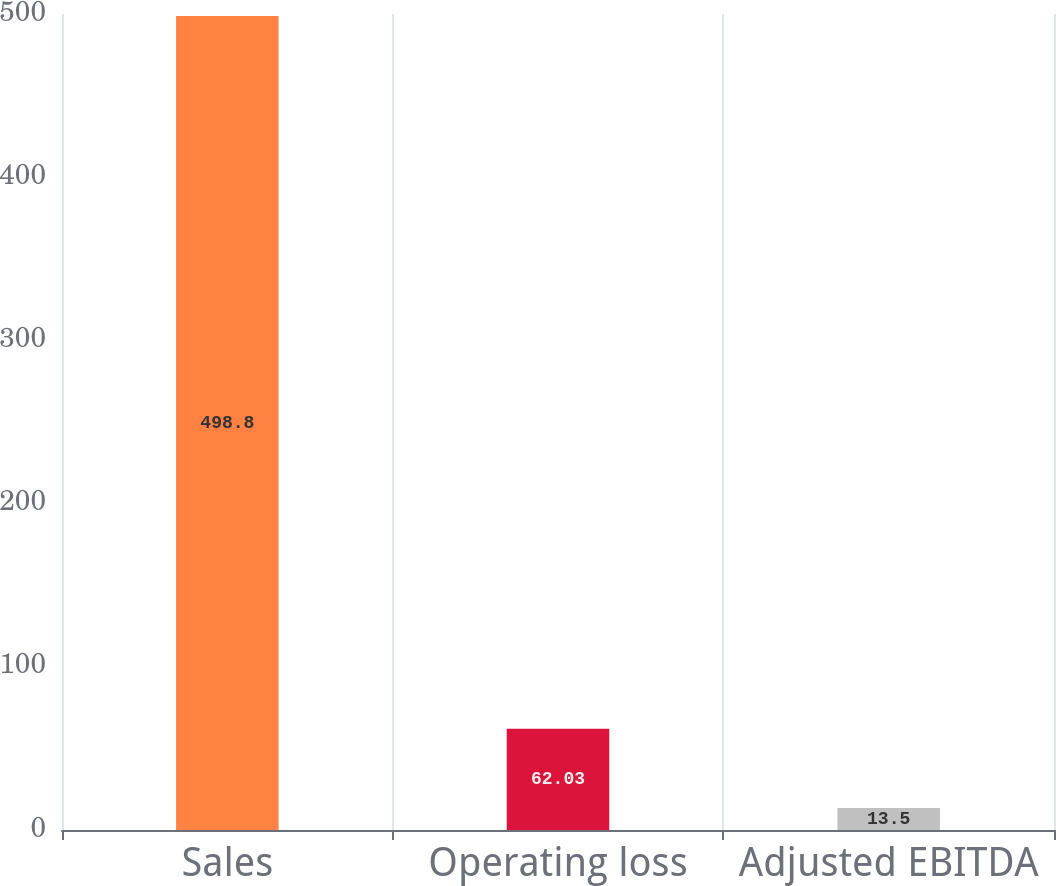Convert chart to OTSL. <chart><loc_0><loc_0><loc_500><loc_500><bar_chart><fcel>Sales<fcel>Operating loss<fcel>Adjusted EBITDA<nl><fcel>498.8<fcel>62.03<fcel>13.5<nl></chart> 